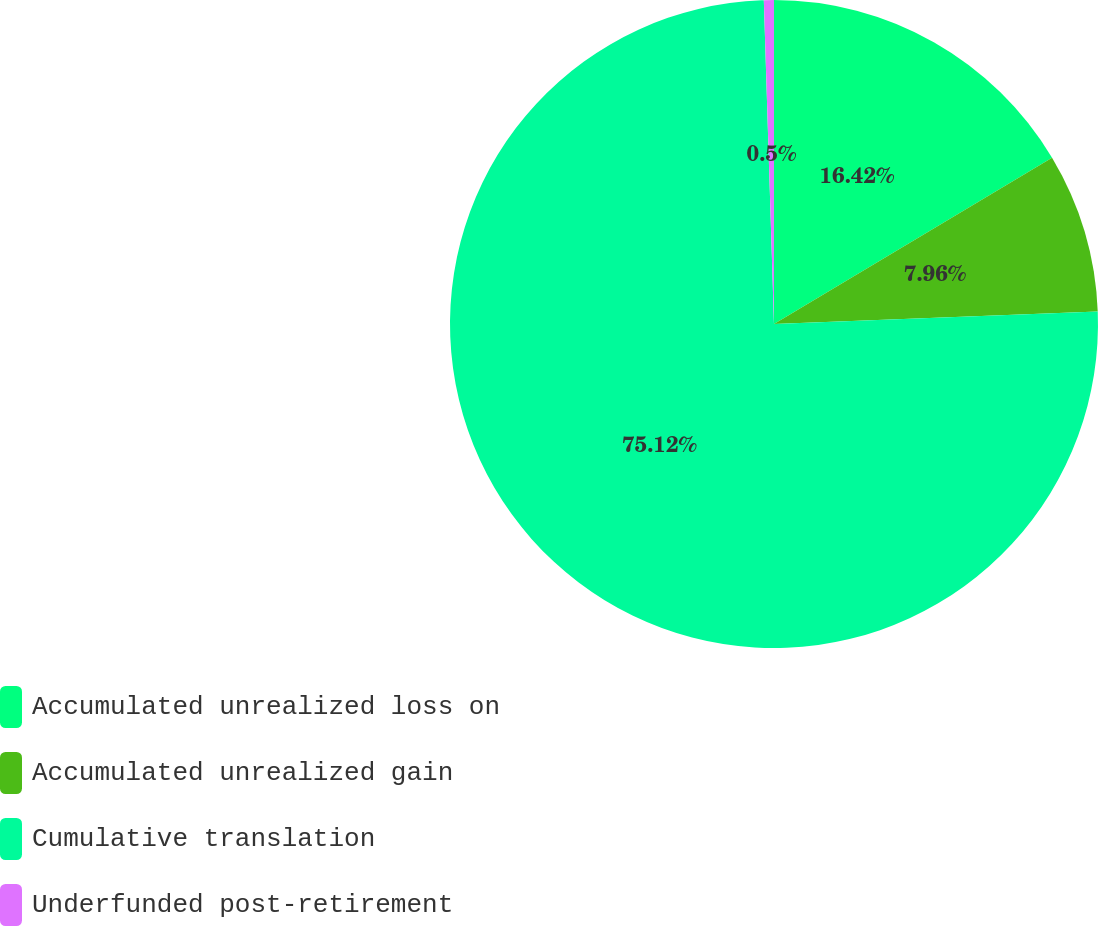<chart> <loc_0><loc_0><loc_500><loc_500><pie_chart><fcel>Accumulated unrealized loss on<fcel>Accumulated unrealized gain<fcel>Cumulative translation<fcel>Underfunded post-retirement<nl><fcel>16.42%<fcel>7.96%<fcel>75.12%<fcel>0.5%<nl></chart> 